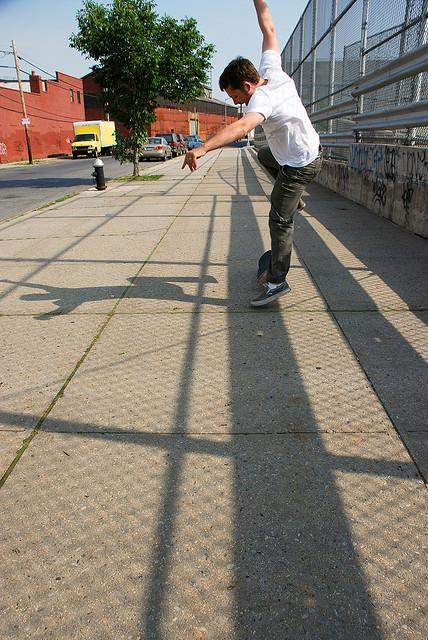The shadow of what is visible?

Choices:
A) skateboarder
B) bird
C) tank
D) cow skateboarder 